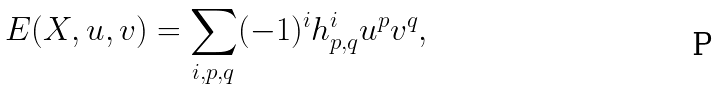<formula> <loc_0><loc_0><loc_500><loc_500>E ( X , u , v ) = \sum _ { i , p , q } ( - 1 ) ^ { i } h _ { p , q } ^ { i } u ^ { p } v ^ { q } ,</formula> 